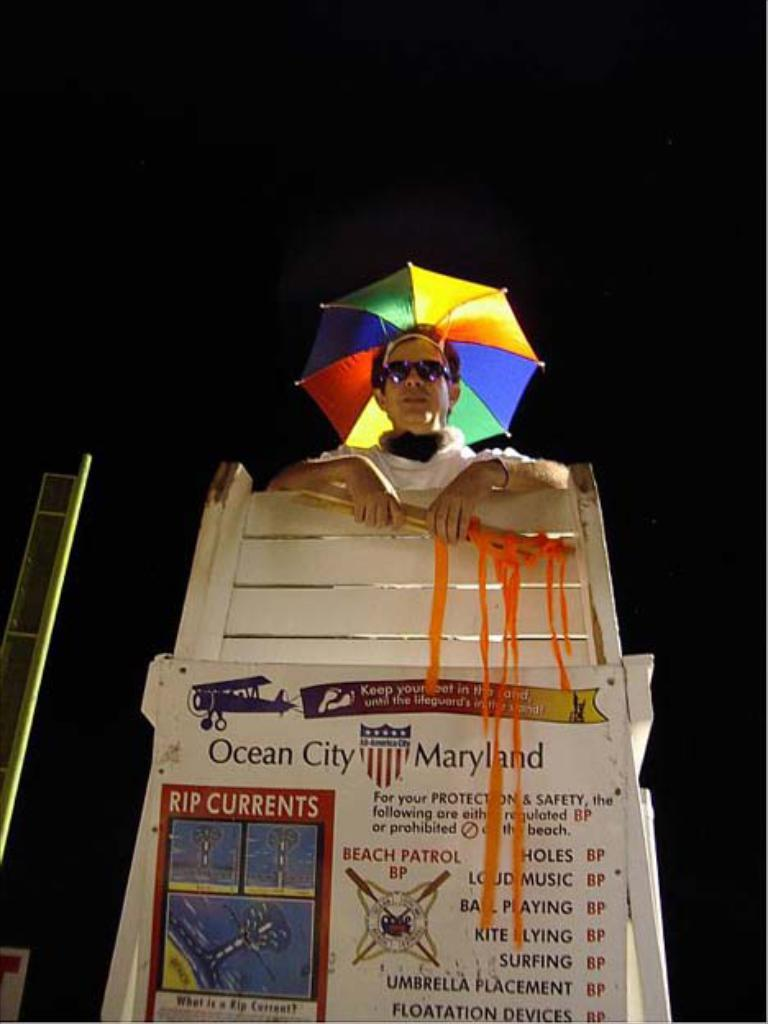What is the person in the image holding? There is a person holding something in the image. What is located at the bottom of the image? There is a board at the bottom of the image. What can be used for protection from rain in the image? There is an umbrella in the image. What is on the left side of the image? There is a pole on the left side of the image. How would you describe the lighting in the image? The background of the image is dark. What type of country is depicted in the image? There is no country depicted in the image; it is a person holding something with a board, umbrella, and pole in the background. How many hens can be seen in the image? There are no hens present in the image. 